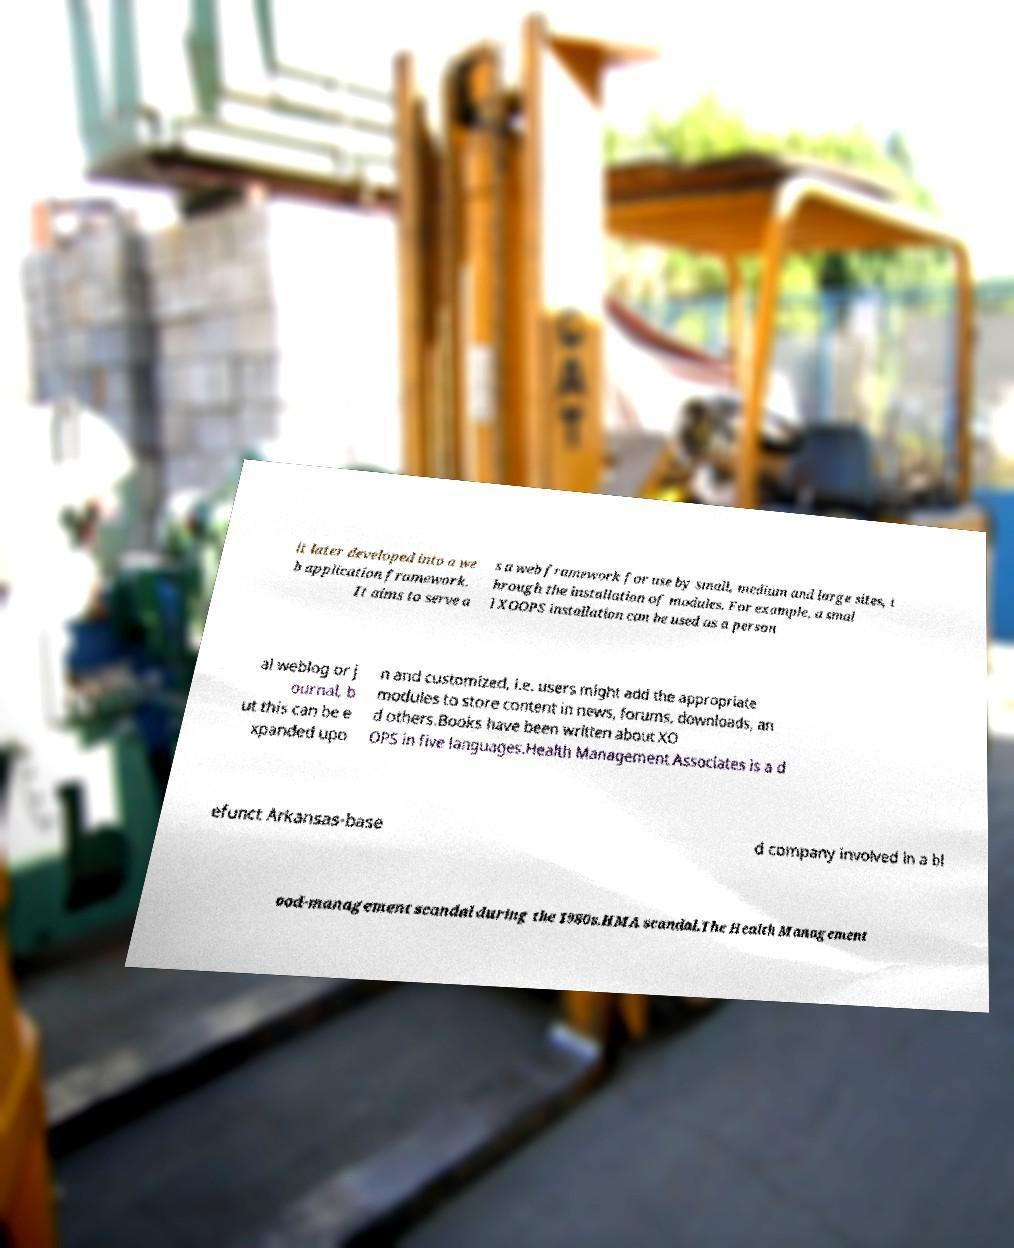Can you read and provide the text displayed in the image?This photo seems to have some interesting text. Can you extract and type it out for me? it later developed into a we b application framework. It aims to serve a s a web framework for use by small, medium and large sites, t hrough the installation of modules. For example, a smal l XOOPS installation can be used as a person al weblog or j ournal, b ut this can be e xpanded upo n and customized, i.e. users might add the appropriate modules to store content in news, forums, downloads, an d others.Books have been written about XO OPS in five languages.Health Management Associates is a d efunct Arkansas-base d company involved in a bl ood-management scandal during the 1980s.HMA scandal.The Health Management 